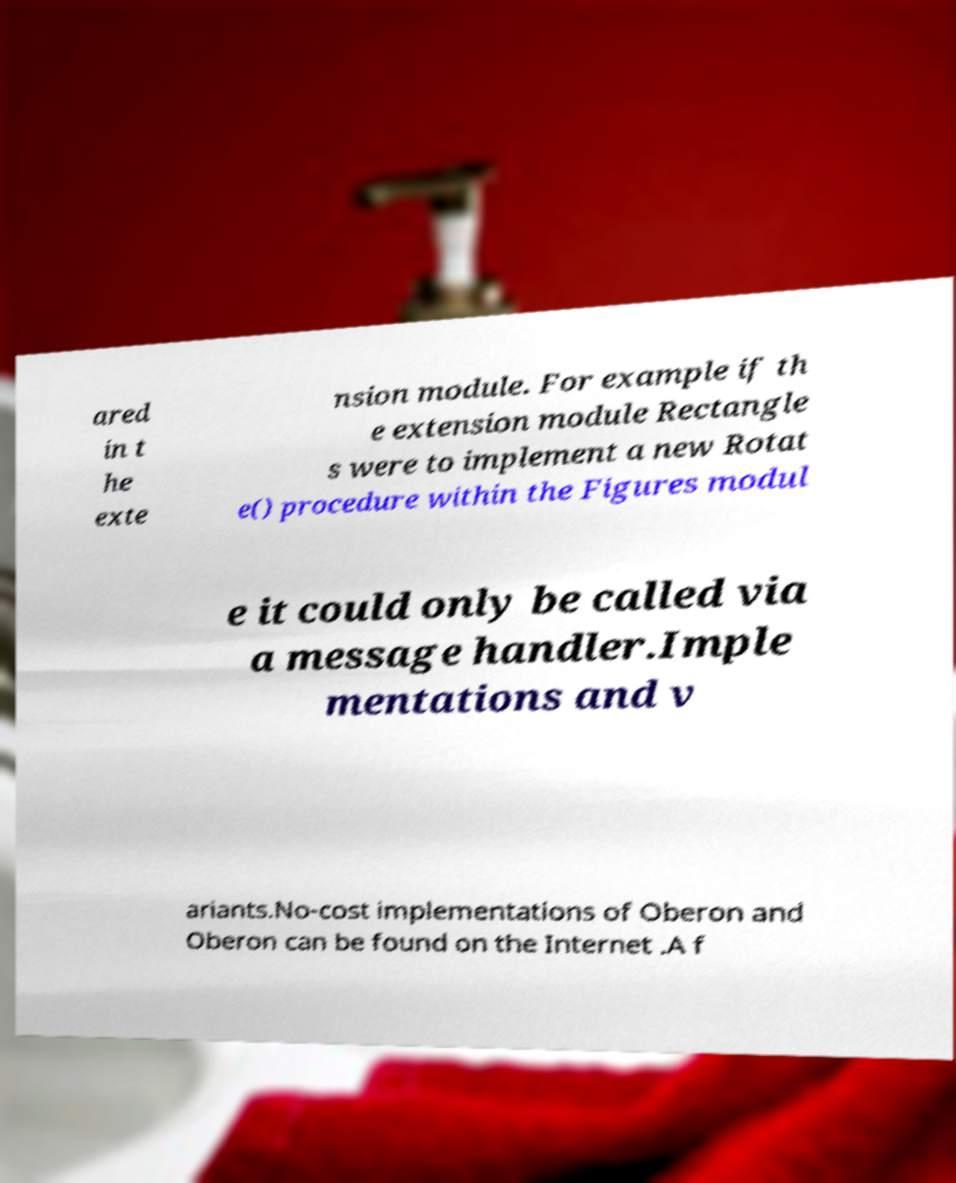Could you assist in decoding the text presented in this image and type it out clearly? ared in t he exte nsion module. For example if th e extension module Rectangle s were to implement a new Rotat e() procedure within the Figures modul e it could only be called via a message handler.Imple mentations and v ariants.No-cost implementations of Oberon and Oberon can be found on the Internet .A f 